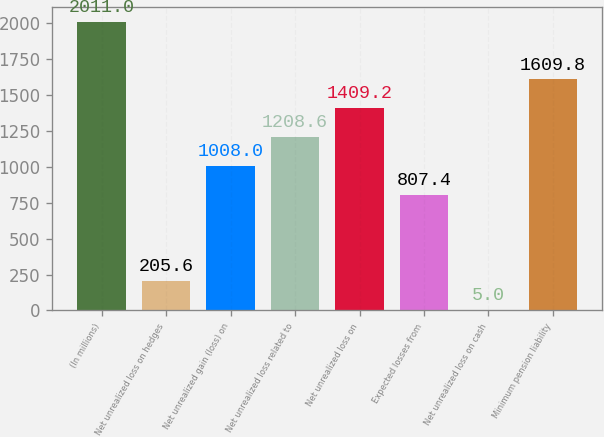Convert chart to OTSL. <chart><loc_0><loc_0><loc_500><loc_500><bar_chart><fcel>(In millions)<fcel>Net unrealized loss on hedges<fcel>Net unrealized gain (loss) on<fcel>Net unrealized loss related to<fcel>Net unrealized loss on<fcel>Expected losses from<fcel>Net unrealized loss on cash<fcel>Minimum pension liability<nl><fcel>2011<fcel>205.6<fcel>1008<fcel>1208.6<fcel>1409.2<fcel>807.4<fcel>5<fcel>1609.8<nl></chart> 